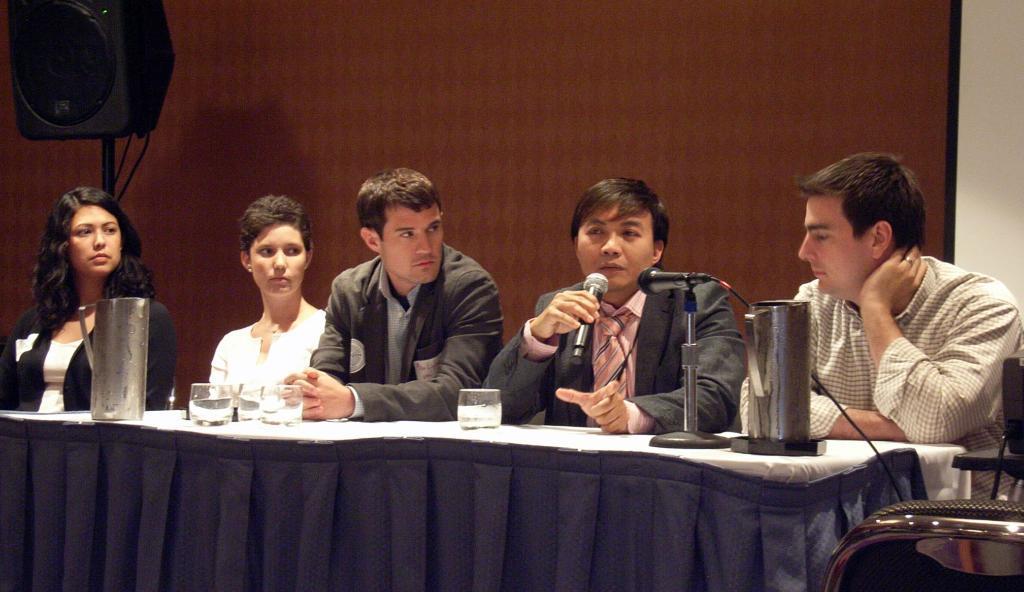Could you give a brief overview of what you see in this image? In this image there is a table in the foreground on which there are mugs, glasses contain water, mike, cloth, in front of table there are few people, one person holding a mike, backside of them, there is a wooden wall , in front of the wall there is a speaker in the top left, in the bottom right there might be a chair. 